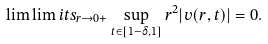<formula> <loc_0><loc_0><loc_500><loc_500>\lim \lim i t s _ { r \to 0 + } \sup _ { t \in [ 1 - \delta , 1 ] } r ^ { 2 } | v ( r , t ) | = 0 .</formula> 